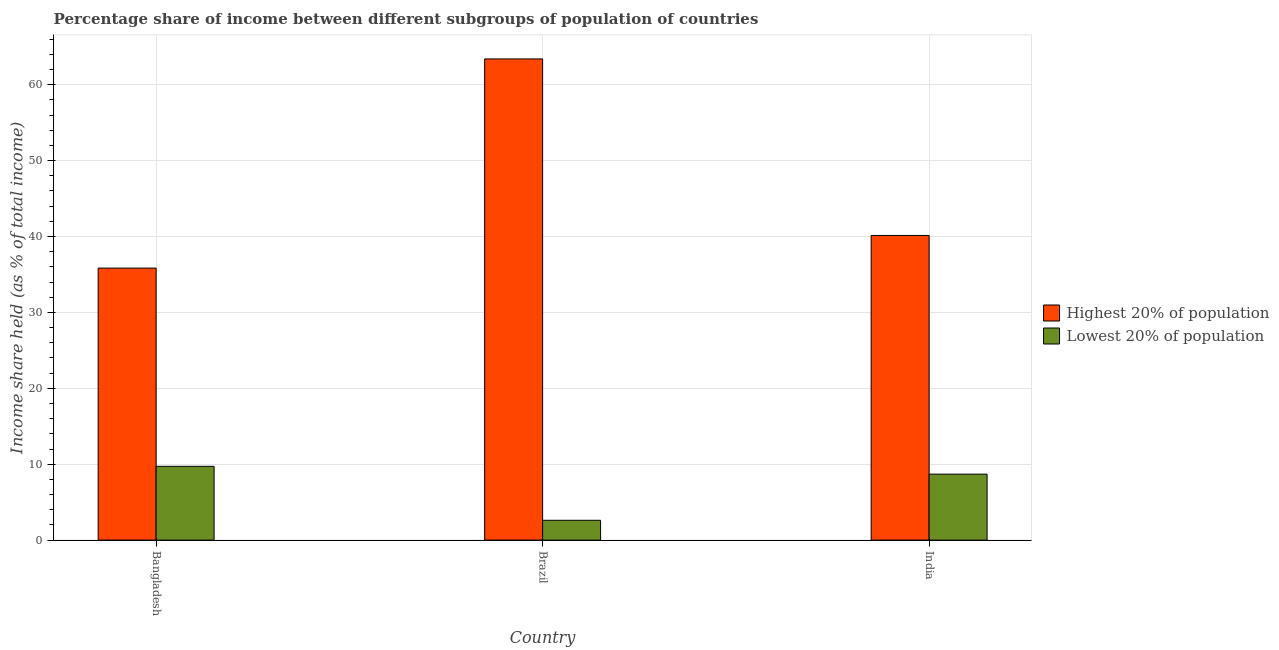How many different coloured bars are there?
Ensure brevity in your answer.  2. How many groups of bars are there?
Ensure brevity in your answer.  3. Are the number of bars per tick equal to the number of legend labels?
Your answer should be very brief. Yes. How many bars are there on the 3rd tick from the left?
Make the answer very short. 2. What is the income share held by lowest 20% of the population in Bangladesh?
Offer a terse response. 9.72. Across all countries, what is the maximum income share held by lowest 20% of the population?
Keep it short and to the point. 9.72. Across all countries, what is the minimum income share held by highest 20% of the population?
Give a very brief answer. 35.84. What is the total income share held by highest 20% of the population in the graph?
Your response must be concise. 139.38. What is the difference between the income share held by lowest 20% of the population in Bangladesh and that in Brazil?
Ensure brevity in your answer.  7.11. What is the difference between the income share held by lowest 20% of the population in Bangladesh and the income share held by highest 20% of the population in India?
Provide a succinct answer. -30.42. What is the average income share held by lowest 20% of the population per country?
Provide a succinct answer. 7.01. What is the difference between the income share held by lowest 20% of the population and income share held by highest 20% of the population in Brazil?
Ensure brevity in your answer.  -60.79. What is the ratio of the income share held by highest 20% of the population in Bangladesh to that in Brazil?
Provide a succinct answer. 0.57. Is the income share held by lowest 20% of the population in Bangladesh less than that in Brazil?
Provide a succinct answer. No. Is the difference between the income share held by highest 20% of the population in Bangladesh and India greater than the difference between the income share held by lowest 20% of the population in Bangladesh and India?
Make the answer very short. No. What is the difference between the highest and the second highest income share held by highest 20% of the population?
Give a very brief answer. 23.26. What is the difference between the highest and the lowest income share held by highest 20% of the population?
Your answer should be very brief. 27.56. What does the 2nd bar from the left in Brazil represents?
Your response must be concise. Lowest 20% of population. What does the 1st bar from the right in Bangladesh represents?
Your answer should be very brief. Lowest 20% of population. How many bars are there?
Keep it short and to the point. 6. Are all the bars in the graph horizontal?
Provide a succinct answer. No. How many countries are there in the graph?
Your answer should be compact. 3. What is the difference between two consecutive major ticks on the Y-axis?
Keep it short and to the point. 10. Does the graph contain any zero values?
Offer a very short reply. No. Where does the legend appear in the graph?
Provide a short and direct response. Center right. How many legend labels are there?
Give a very brief answer. 2. What is the title of the graph?
Your answer should be compact. Percentage share of income between different subgroups of population of countries. Does "Long-term debt" appear as one of the legend labels in the graph?
Keep it short and to the point. No. What is the label or title of the Y-axis?
Your answer should be compact. Income share held (as % of total income). What is the Income share held (as % of total income) of Highest 20% of population in Bangladesh?
Offer a very short reply. 35.84. What is the Income share held (as % of total income) of Lowest 20% of population in Bangladesh?
Provide a succinct answer. 9.72. What is the Income share held (as % of total income) of Highest 20% of population in Brazil?
Offer a very short reply. 63.4. What is the Income share held (as % of total income) of Lowest 20% of population in Brazil?
Give a very brief answer. 2.61. What is the Income share held (as % of total income) of Highest 20% of population in India?
Your answer should be very brief. 40.14. What is the Income share held (as % of total income) in Lowest 20% of population in India?
Your answer should be compact. 8.69. Across all countries, what is the maximum Income share held (as % of total income) in Highest 20% of population?
Provide a short and direct response. 63.4. Across all countries, what is the maximum Income share held (as % of total income) of Lowest 20% of population?
Offer a terse response. 9.72. Across all countries, what is the minimum Income share held (as % of total income) in Highest 20% of population?
Your response must be concise. 35.84. Across all countries, what is the minimum Income share held (as % of total income) of Lowest 20% of population?
Make the answer very short. 2.61. What is the total Income share held (as % of total income) of Highest 20% of population in the graph?
Your answer should be very brief. 139.38. What is the total Income share held (as % of total income) in Lowest 20% of population in the graph?
Your answer should be very brief. 21.02. What is the difference between the Income share held (as % of total income) in Highest 20% of population in Bangladesh and that in Brazil?
Offer a terse response. -27.56. What is the difference between the Income share held (as % of total income) in Lowest 20% of population in Bangladesh and that in Brazil?
Make the answer very short. 7.11. What is the difference between the Income share held (as % of total income) in Highest 20% of population in Brazil and that in India?
Provide a short and direct response. 23.26. What is the difference between the Income share held (as % of total income) of Lowest 20% of population in Brazil and that in India?
Your answer should be very brief. -6.08. What is the difference between the Income share held (as % of total income) of Highest 20% of population in Bangladesh and the Income share held (as % of total income) of Lowest 20% of population in Brazil?
Provide a short and direct response. 33.23. What is the difference between the Income share held (as % of total income) of Highest 20% of population in Bangladesh and the Income share held (as % of total income) of Lowest 20% of population in India?
Ensure brevity in your answer.  27.15. What is the difference between the Income share held (as % of total income) of Highest 20% of population in Brazil and the Income share held (as % of total income) of Lowest 20% of population in India?
Your answer should be very brief. 54.71. What is the average Income share held (as % of total income) in Highest 20% of population per country?
Provide a succinct answer. 46.46. What is the average Income share held (as % of total income) in Lowest 20% of population per country?
Give a very brief answer. 7.01. What is the difference between the Income share held (as % of total income) in Highest 20% of population and Income share held (as % of total income) in Lowest 20% of population in Bangladesh?
Provide a succinct answer. 26.12. What is the difference between the Income share held (as % of total income) of Highest 20% of population and Income share held (as % of total income) of Lowest 20% of population in Brazil?
Ensure brevity in your answer.  60.79. What is the difference between the Income share held (as % of total income) in Highest 20% of population and Income share held (as % of total income) in Lowest 20% of population in India?
Your answer should be very brief. 31.45. What is the ratio of the Income share held (as % of total income) of Highest 20% of population in Bangladesh to that in Brazil?
Offer a terse response. 0.57. What is the ratio of the Income share held (as % of total income) of Lowest 20% of population in Bangladesh to that in Brazil?
Your response must be concise. 3.72. What is the ratio of the Income share held (as % of total income) in Highest 20% of population in Bangladesh to that in India?
Offer a very short reply. 0.89. What is the ratio of the Income share held (as % of total income) in Lowest 20% of population in Bangladesh to that in India?
Make the answer very short. 1.12. What is the ratio of the Income share held (as % of total income) in Highest 20% of population in Brazil to that in India?
Your answer should be very brief. 1.58. What is the ratio of the Income share held (as % of total income) of Lowest 20% of population in Brazil to that in India?
Ensure brevity in your answer.  0.3. What is the difference between the highest and the second highest Income share held (as % of total income) of Highest 20% of population?
Your answer should be very brief. 23.26. What is the difference between the highest and the lowest Income share held (as % of total income) in Highest 20% of population?
Provide a short and direct response. 27.56. What is the difference between the highest and the lowest Income share held (as % of total income) of Lowest 20% of population?
Ensure brevity in your answer.  7.11. 